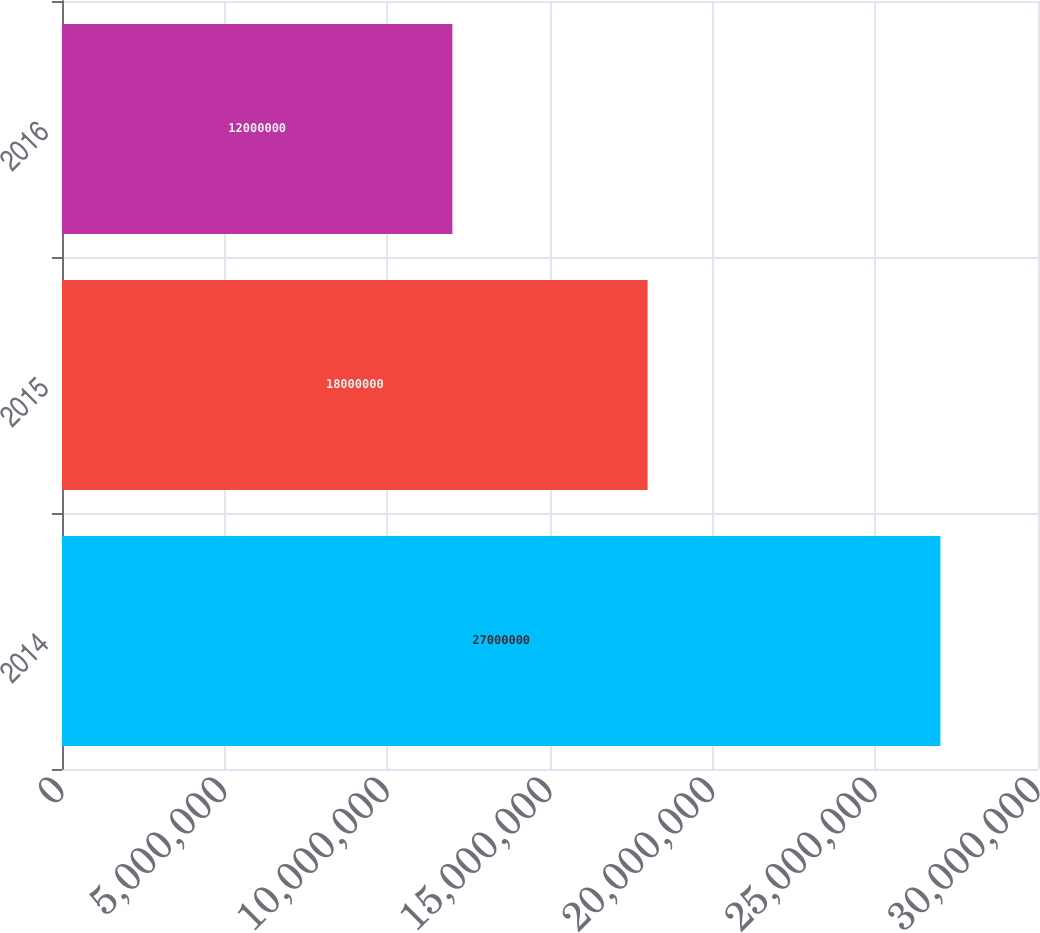<chart> <loc_0><loc_0><loc_500><loc_500><bar_chart><fcel>2014<fcel>2015<fcel>2016<nl><fcel>2.7e+07<fcel>1.8e+07<fcel>1.2e+07<nl></chart> 